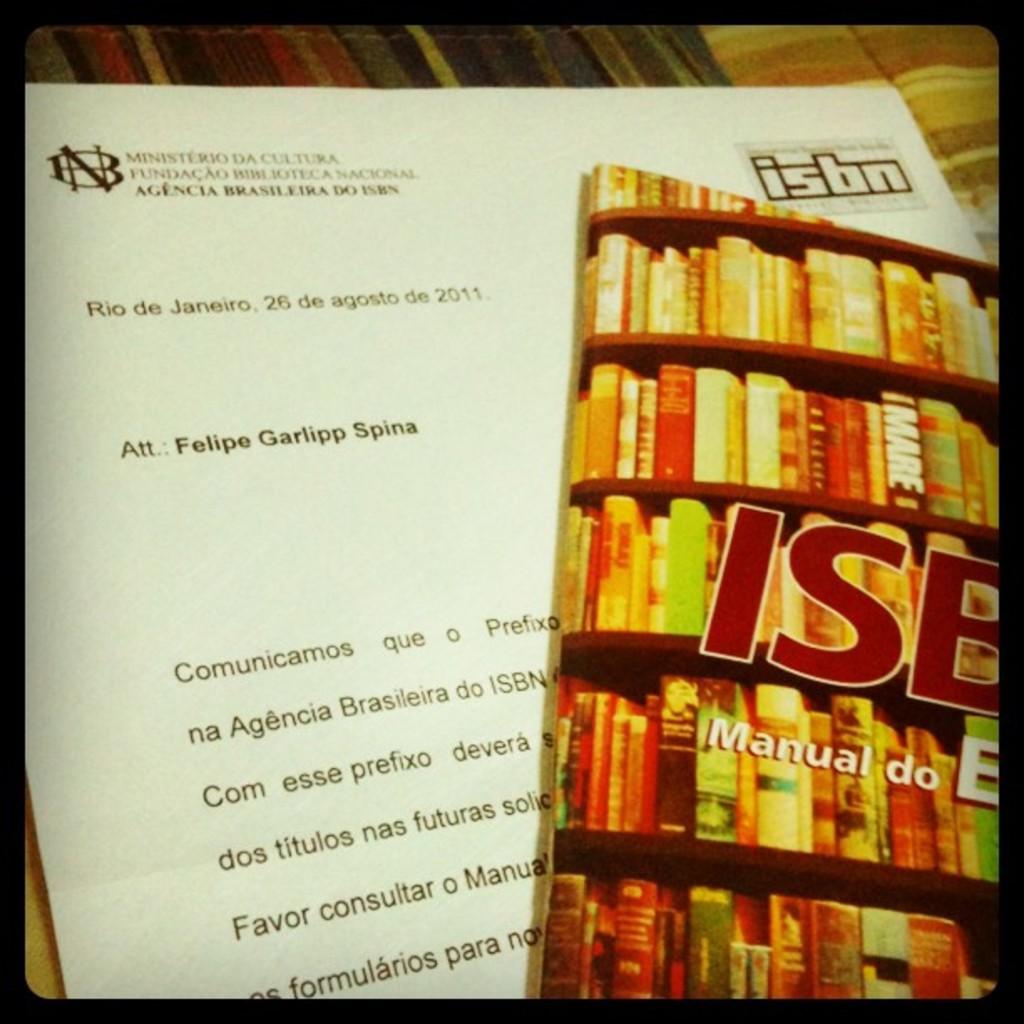What city does this memo reference?
Your answer should be very brief. Rio de janeiro. Who wrote this?
Make the answer very short. Felipe garlipp spina. 